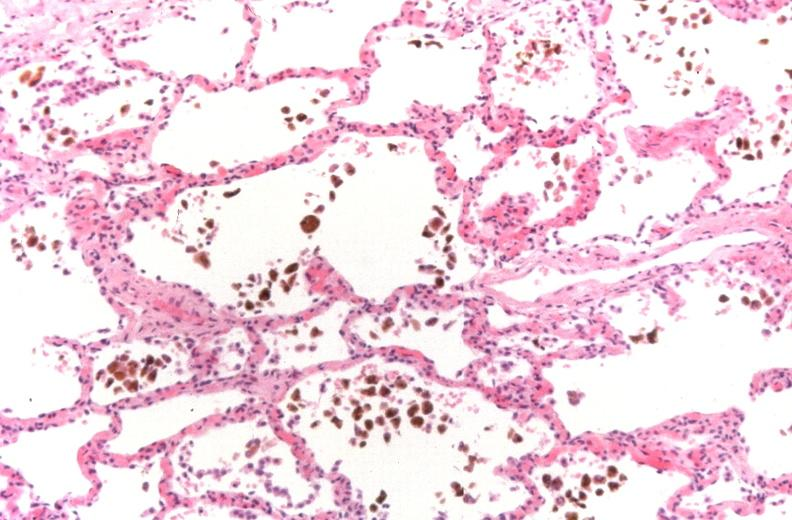does pinworm show lung, congestion, heart failure cells hemosiderin laden macrophages?
Answer the question using a single word or phrase. No 